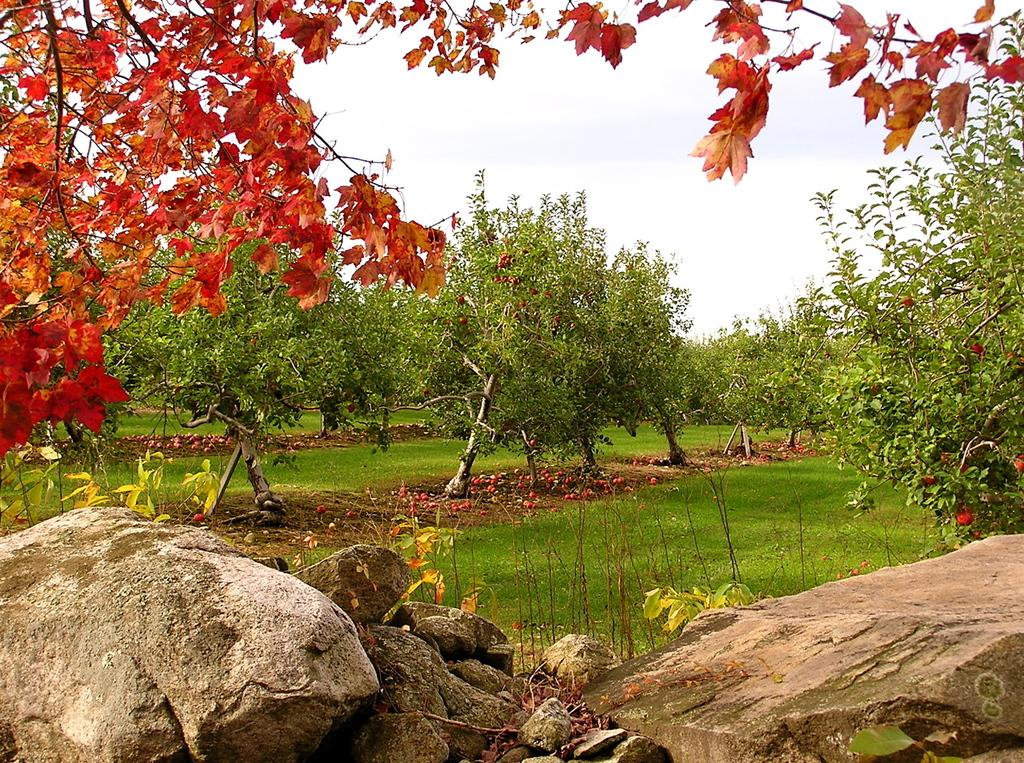What type of natural elements can be seen in the front of the image? There are rocks in the front of the image. What type of vegetation is visible in the background of the image? There are trees in the background of the image. What type of terrain is the trees located on? The trees are on a grassland. What is visible above the trees and rocks in the image? The sky is visible in the image. What type of creature can be seen riding a bike in the image? There is no creature or bike present in the image. What is the texture of the rocks in the image? The texture of the rocks cannot be determined from the image alone, as it only provides visual information. 